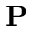<formula> <loc_0><loc_0><loc_500><loc_500>P</formula> 